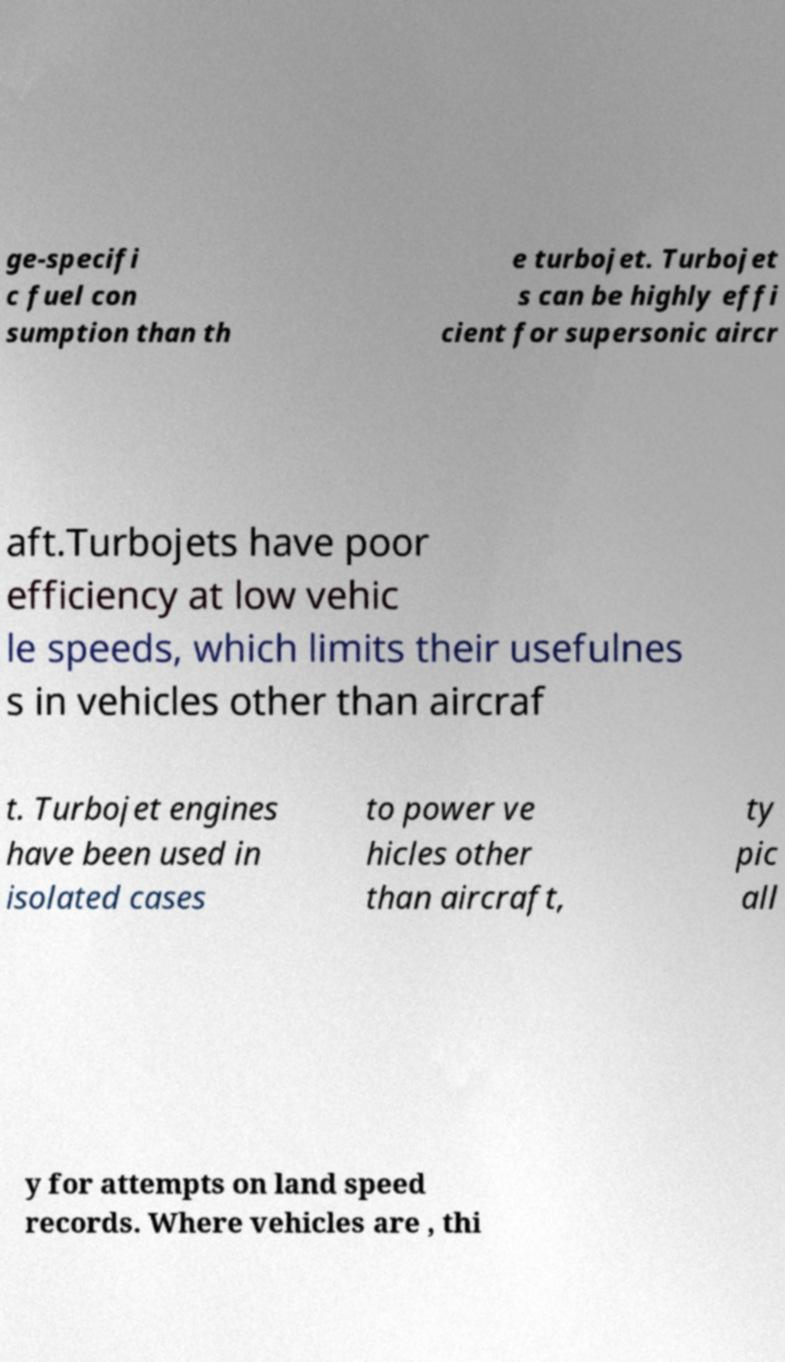Could you assist in decoding the text presented in this image and type it out clearly? ge-specifi c fuel con sumption than th e turbojet. Turbojet s can be highly effi cient for supersonic aircr aft.Turbojets have poor efficiency at low vehic le speeds, which limits their usefulnes s in vehicles other than aircraf t. Turbojet engines have been used in isolated cases to power ve hicles other than aircraft, ty pic all y for attempts on land speed records. Where vehicles are , thi 